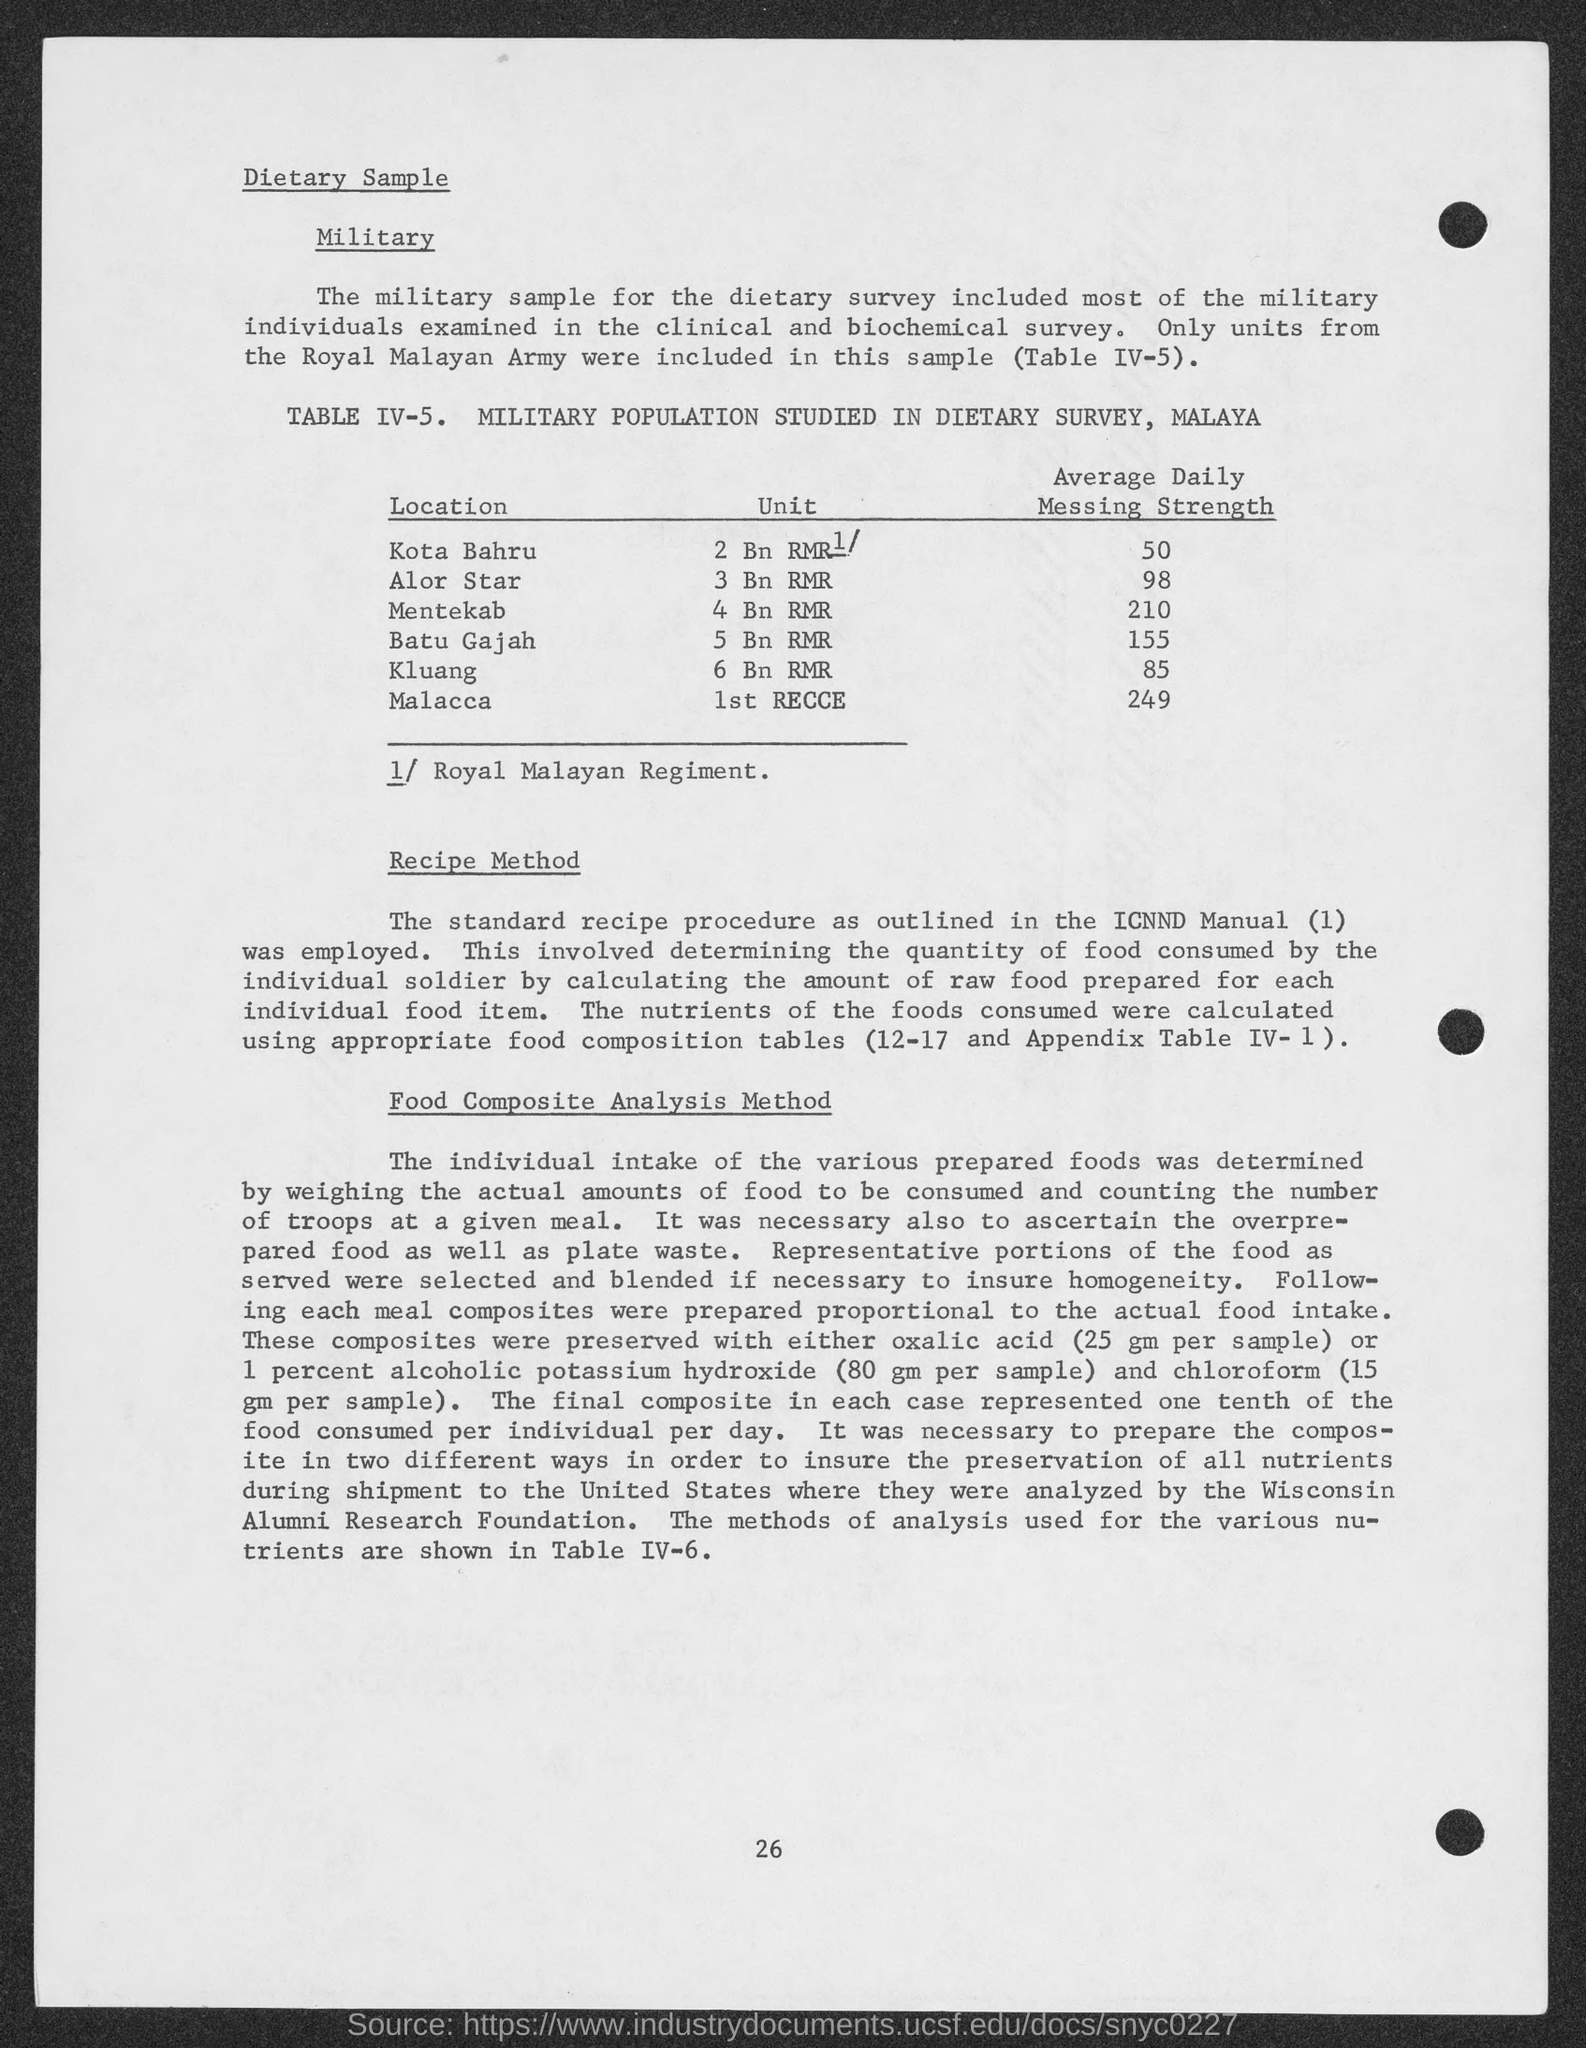What details can you provide about the food composition analysis method mentioned? The food composition analysis method involved weighing the actual amounts of each food consumed and counting the number of portions per meal. The nutrients were then calculated using food composition tables, and samples were preserved with chemicals like oxalic acid or potassium hydroxide for further analysis. 